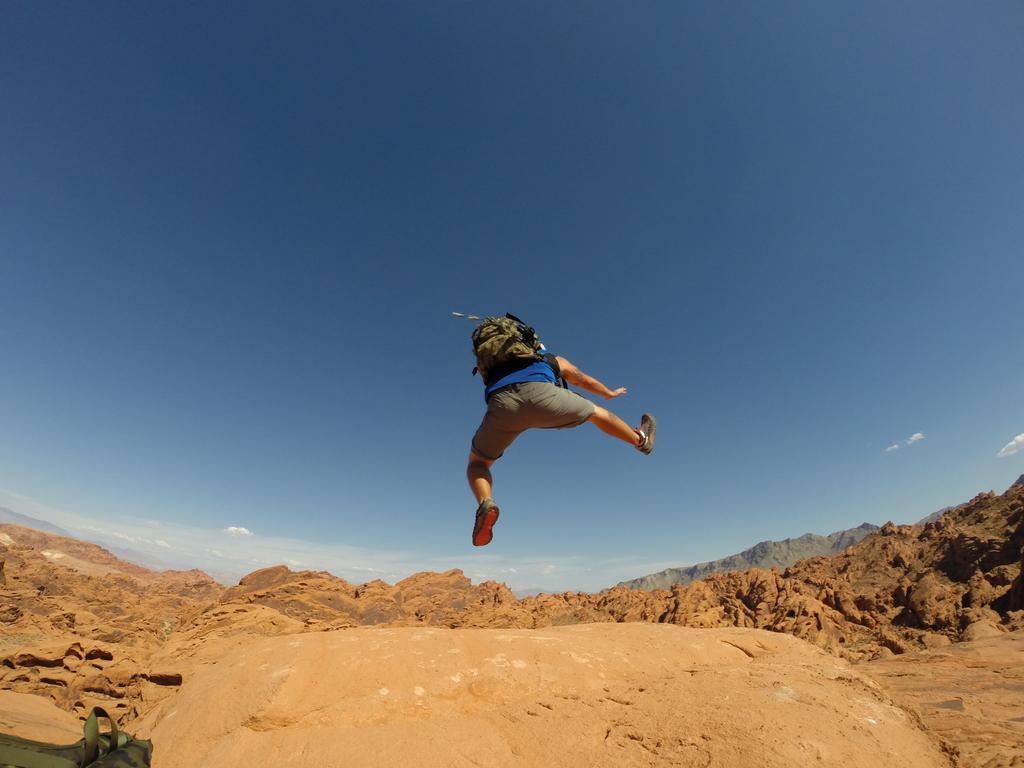Describe this image in one or two sentences. In this image I can see a person in air, the person is wearing blue shirt gray short, and a bag. Background I can see few mountains and the sky is in blue and white color. 